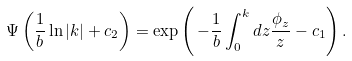Convert formula to latex. <formula><loc_0><loc_0><loc_500><loc_500>\Psi \left ( \frac { 1 } { b } \ln | k | + c _ { 2 } \right ) = \exp \left ( \, - \frac { 1 } { b } \int _ { 0 } ^ { k } d z \frac { \phi _ { z } } { z } - c _ { 1 } \right ) .</formula> 